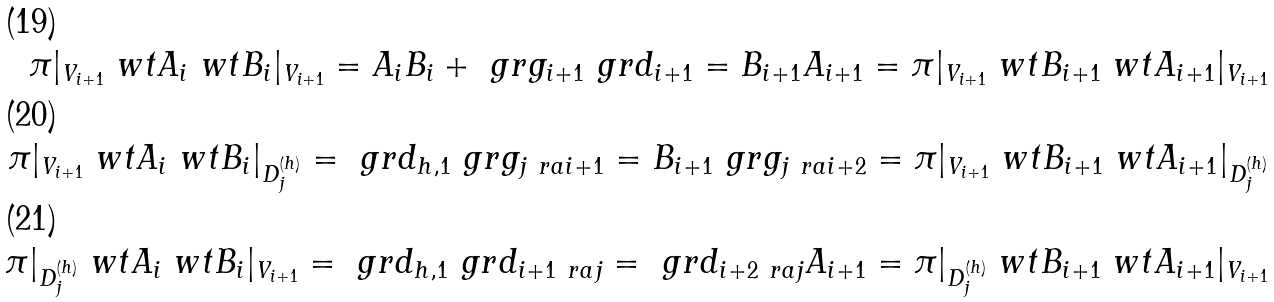Convert formula to latex. <formula><loc_0><loc_0><loc_500><loc_500>\pi | _ { V _ { i + 1 } } \ w t A _ { i } \ w t B _ { i } | _ { V _ { i + 1 } } = A _ { i } B _ { i } + \ g r g _ { i + 1 } \ g r d _ { i + 1 } = B _ { i + 1 } A _ { i + 1 } = \pi | _ { V _ { i + 1 } } \ w t B _ { i + 1 } \ w t A _ { i + 1 } | _ { V _ { i + 1 } } \\ \pi | _ { V _ { i + 1 } } \ w t A _ { i } \ w t B _ { i } | _ { D _ { j } ^ { ( h ) } } = \ g r d _ { h , 1 } \ g r g _ { j \ r a i + 1 } = B _ { i + 1 } \ g r g _ { j \ r a i + 2 } = \pi | _ { V _ { i + 1 } } \ w t B _ { i + 1 } \ w t A _ { i + 1 } | _ { D _ { j } ^ { ( h ) } } \\ \pi | _ { D _ { j } ^ { ( h ) } } \ w t A _ { i } \ w t B _ { i } | _ { V _ { i + 1 } } = \ g r d _ { h , 1 } \ g r d _ { i + 1 \ r a j } = \ g r d _ { i + 2 \ r a j } A _ { i + 1 } = \pi | _ { D _ { j } ^ { ( h ) } } \ w t B _ { i + 1 } \ w t A _ { i + 1 } | _ { V _ { i + 1 } }</formula> 